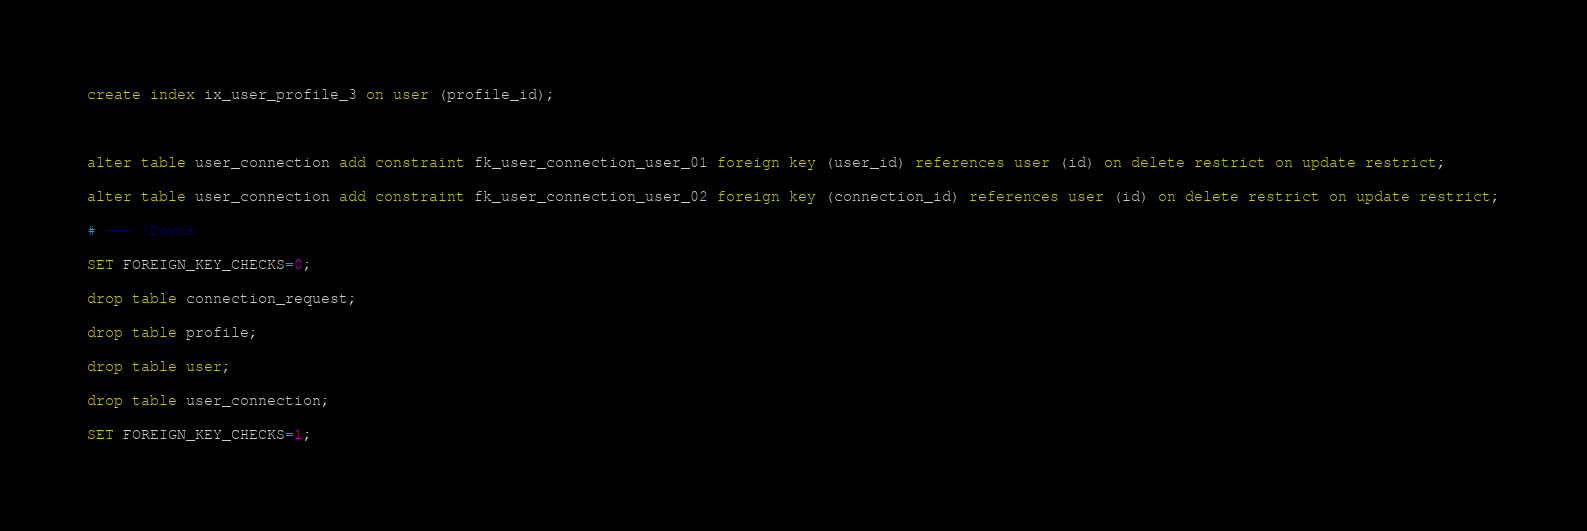<code> <loc_0><loc_0><loc_500><loc_500><_SQL_>create index ix_user_profile_3 on user (profile_id);



alter table user_connection add constraint fk_user_connection_user_01 foreign key (user_id) references user (id) on delete restrict on update restrict;

alter table user_connection add constraint fk_user_connection_user_02 foreign key (connection_id) references user (id) on delete restrict on update restrict;

# --- !Downs

SET FOREIGN_KEY_CHECKS=0;

drop table connection_request;

drop table profile;

drop table user;

drop table user_connection;

SET FOREIGN_KEY_CHECKS=1;

</code> 